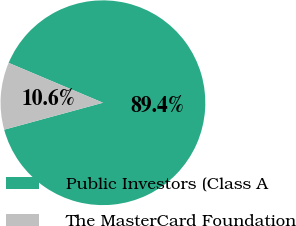Convert chart. <chart><loc_0><loc_0><loc_500><loc_500><pie_chart><fcel>Public Investors (Class A<fcel>The MasterCard Foundation<nl><fcel>89.4%<fcel>10.6%<nl></chart> 